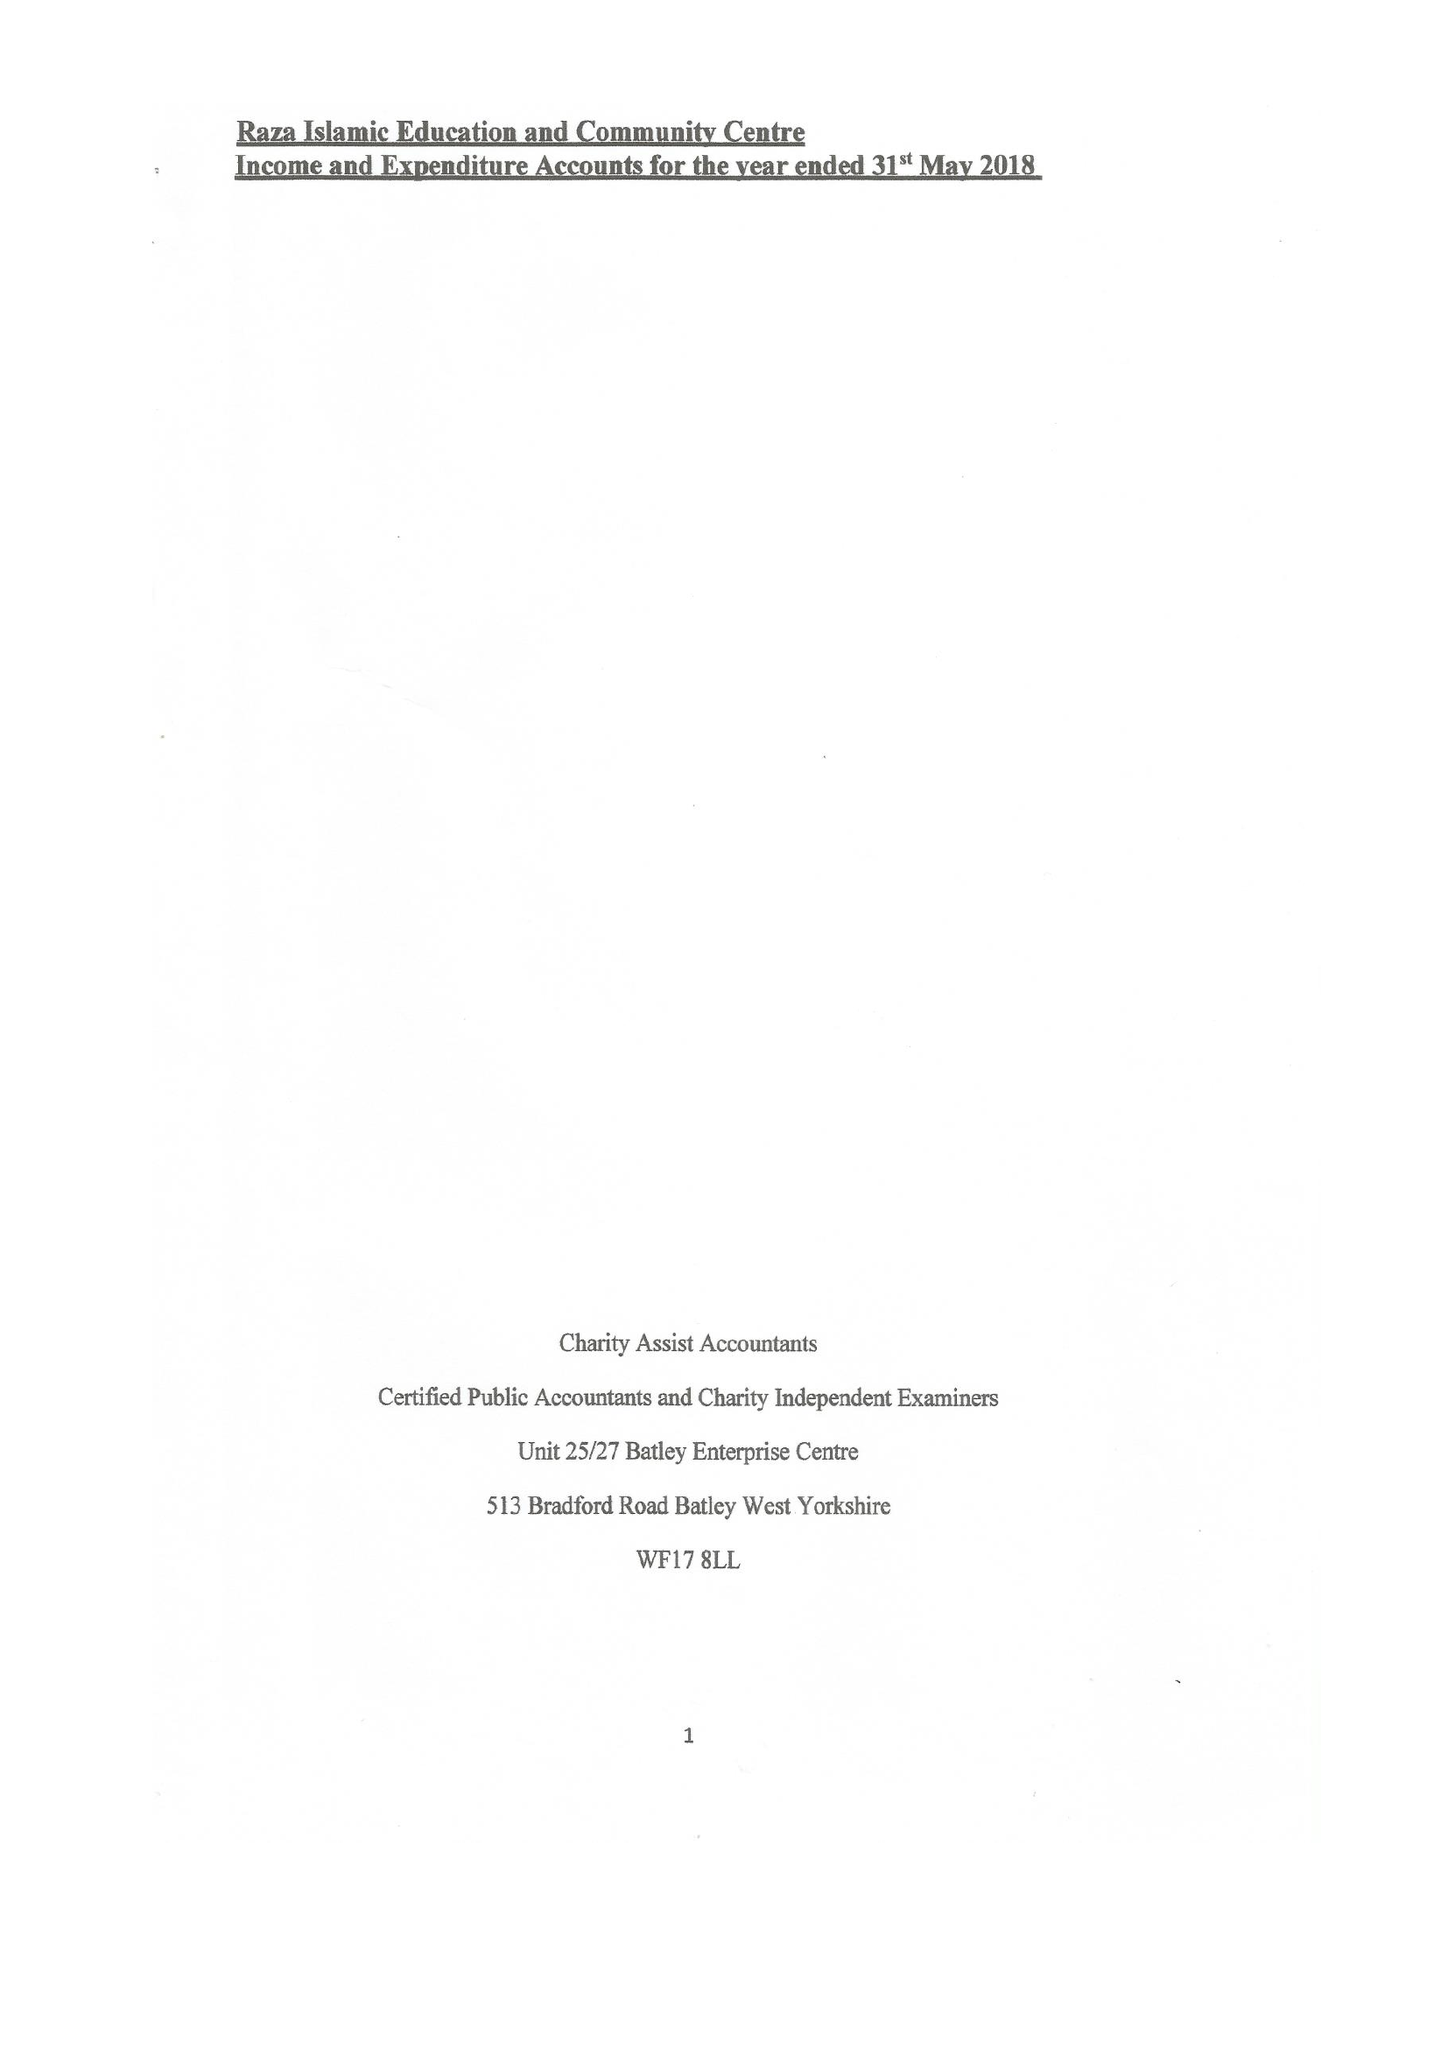What is the value for the income_annually_in_british_pounds?
Answer the question using a single word or phrase. 71507.00 